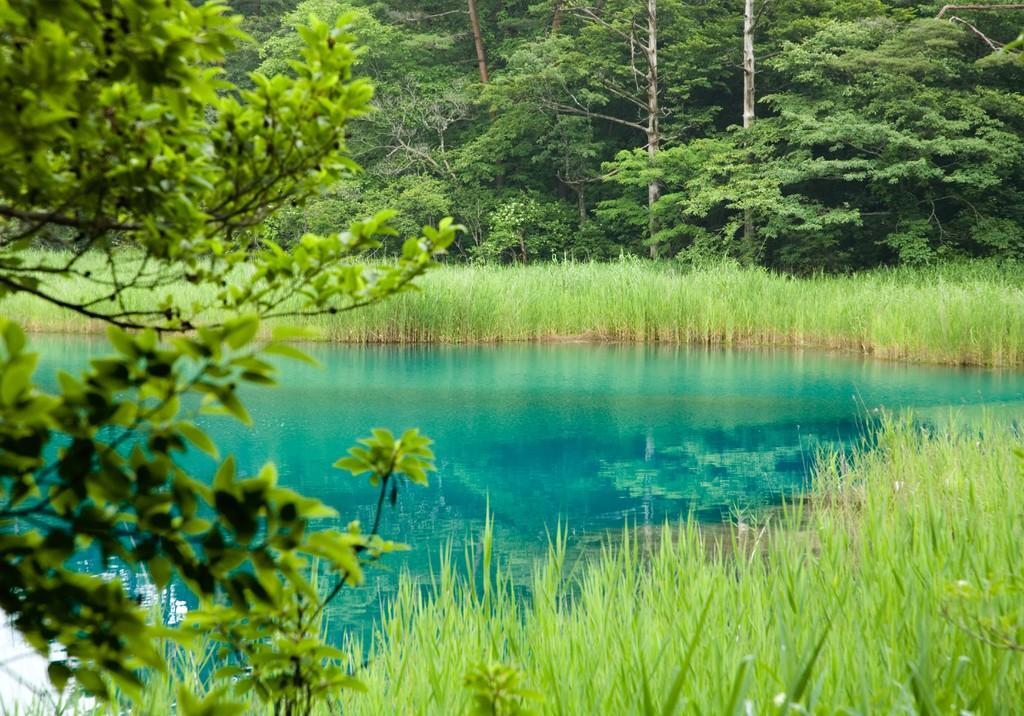What is the main feature in the center of the image? There is a pond in the center of the image. What can be seen in the background of the image? There are trees in the background of the image. What type of vegetation is visible at the bottom of the image? There is grass visible at the bottom of the image. How many sheep are grazing in the grass in the image? There are no sheep present in the image; it features a pond, trees, and grass. 